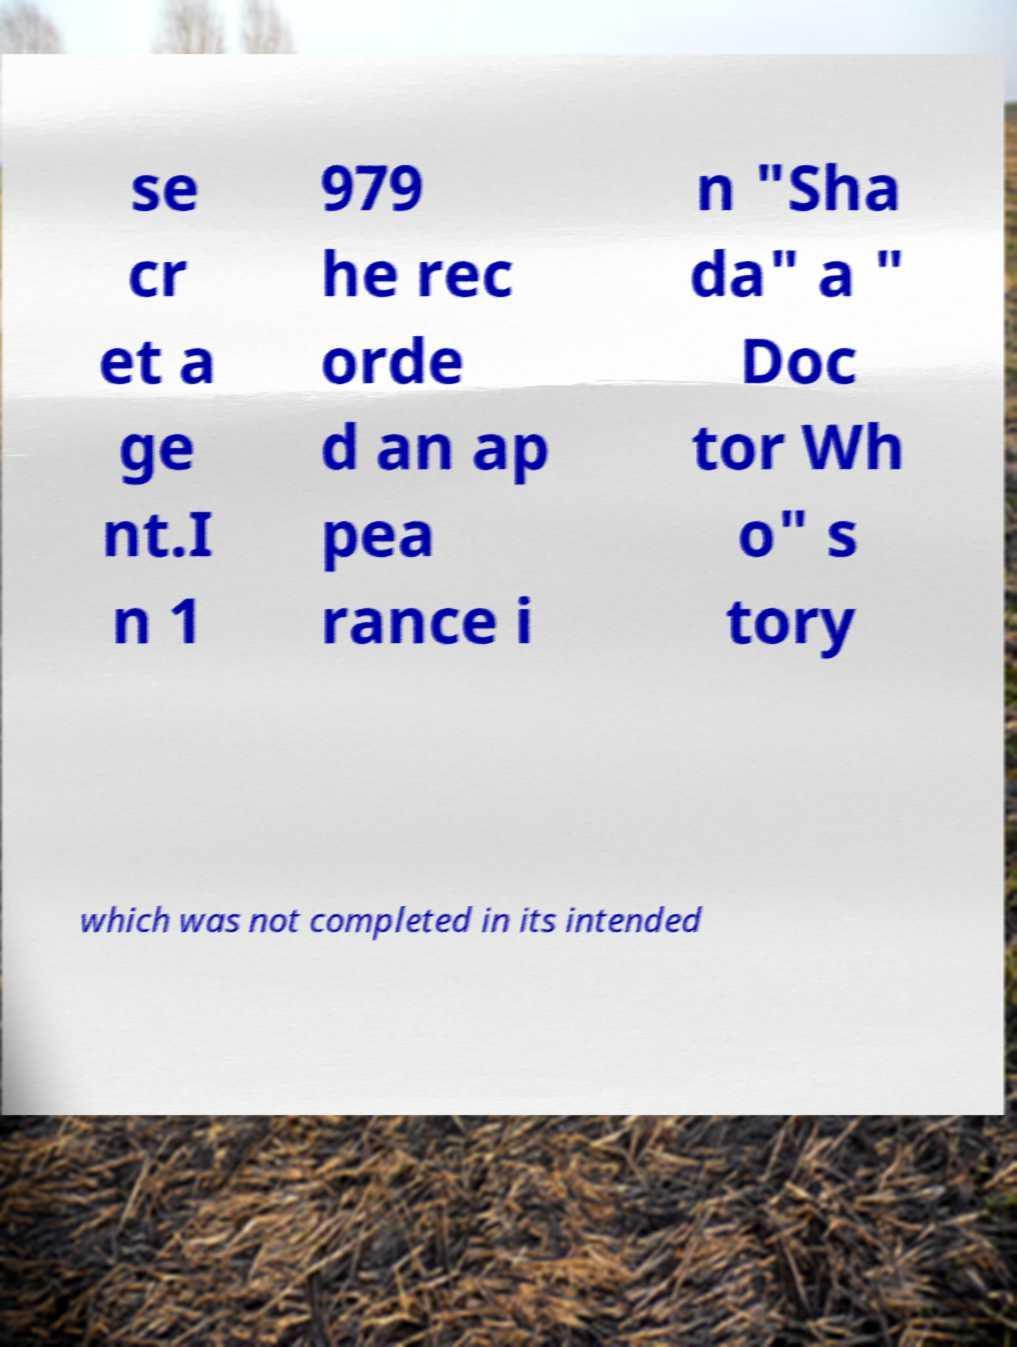Please read and relay the text visible in this image. What does it say? se cr et a ge nt.I n 1 979 he rec orde d an ap pea rance i n "Sha da" a " Doc tor Wh o" s tory which was not completed in its intended 